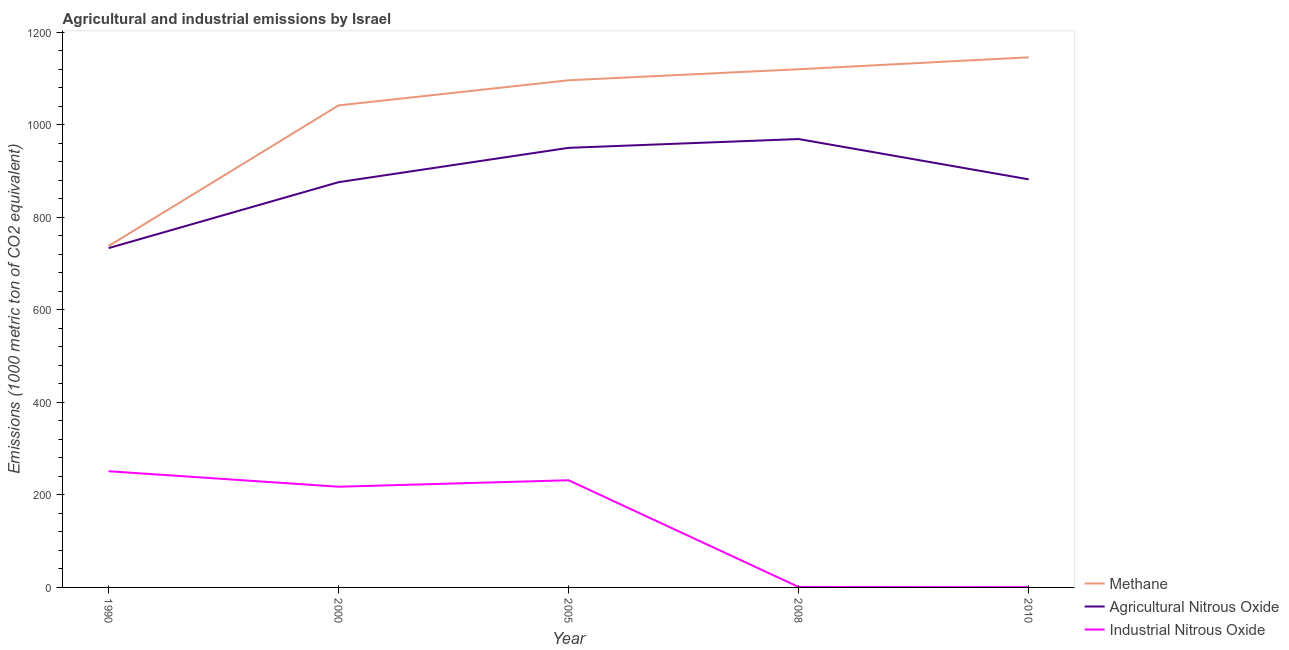What is the amount of methane emissions in 2010?
Your response must be concise. 1145.5. Across all years, what is the maximum amount of agricultural nitrous oxide emissions?
Make the answer very short. 968.9. Across all years, what is the minimum amount of methane emissions?
Give a very brief answer. 737.7. In which year was the amount of methane emissions maximum?
Ensure brevity in your answer.  2010. In which year was the amount of agricultural nitrous oxide emissions minimum?
Offer a terse response. 1990. What is the total amount of industrial nitrous oxide emissions in the graph?
Ensure brevity in your answer.  701.9. What is the difference between the amount of agricultural nitrous oxide emissions in 2005 and that in 2010?
Give a very brief answer. 68.1. What is the difference between the amount of industrial nitrous oxide emissions in 2010 and the amount of agricultural nitrous oxide emissions in 2008?
Ensure brevity in your answer.  -968.3. What is the average amount of industrial nitrous oxide emissions per year?
Provide a short and direct response. 140.38. In the year 2005, what is the difference between the amount of industrial nitrous oxide emissions and amount of methane emissions?
Give a very brief answer. -864.3. In how many years, is the amount of agricultural nitrous oxide emissions greater than 1120 metric ton?
Your answer should be compact. 0. What is the ratio of the amount of industrial nitrous oxide emissions in 2005 to that in 2008?
Your response must be concise. 231.6. Is the amount of methane emissions in 1990 less than that in 2008?
Offer a terse response. Yes. Is the difference between the amount of agricultural nitrous oxide emissions in 2000 and 2008 greater than the difference between the amount of methane emissions in 2000 and 2008?
Keep it short and to the point. No. What is the difference between the highest and the lowest amount of industrial nitrous oxide emissions?
Offer a terse response. 250.5. Is it the case that in every year, the sum of the amount of methane emissions and amount of agricultural nitrous oxide emissions is greater than the amount of industrial nitrous oxide emissions?
Make the answer very short. Yes. Does the amount of agricultural nitrous oxide emissions monotonically increase over the years?
Provide a short and direct response. No. How many lines are there?
Provide a short and direct response. 3. What is the difference between two consecutive major ticks on the Y-axis?
Keep it short and to the point. 200. Does the graph contain grids?
Offer a terse response. No. What is the title of the graph?
Ensure brevity in your answer.  Agricultural and industrial emissions by Israel. Does "Ages 15-20" appear as one of the legend labels in the graph?
Provide a succinct answer. No. What is the label or title of the X-axis?
Provide a succinct answer. Year. What is the label or title of the Y-axis?
Give a very brief answer. Emissions (1000 metric ton of CO2 equivalent). What is the Emissions (1000 metric ton of CO2 equivalent) of Methane in 1990?
Make the answer very short. 737.7. What is the Emissions (1000 metric ton of CO2 equivalent) of Agricultural Nitrous Oxide in 1990?
Your answer should be very brief. 733.2. What is the Emissions (1000 metric ton of CO2 equivalent) in Industrial Nitrous Oxide in 1990?
Provide a short and direct response. 251.1. What is the Emissions (1000 metric ton of CO2 equivalent) of Methane in 2000?
Your answer should be compact. 1041.6. What is the Emissions (1000 metric ton of CO2 equivalent) in Agricultural Nitrous Oxide in 2000?
Give a very brief answer. 875.7. What is the Emissions (1000 metric ton of CO2 equivalent) of Industrial Nitrous Oxide in 2000?
Provide a succinct answer. 217.6. What is the Emissions (1000 metric ton of CO2 equivalent) in Methane in 2005?
Provide a succinct answer. 1095.9. What is the Emissions (1000 metric ton of CO2 equivalent) of Agricultural Nitrous Oxide in 2005?
Offer a very short reply. 949.9. What is the Emissions (1000 metric ton of CO2 equivalent) of Industrial Nitrous Oxide in 2005?
Keep it short and to the point. 231.6. What is the Emissions (1000 metric ton of CO2 equivalent) of Methane in 2008?
Your answer should be very brief. 1119.7. What is the Emissions (1000 metric ton of CO2 equivalent) of Agricultural Nitrous Oxide in 2008?
Keep it short and to the point. 968.9. What is the Emissions (1000 metric ton of CO2 equivalent) of Industrial Nitrous Oxide in 2008?
Make the answer very short. 1. What is the Emissions (1000 metric ton of CO2 equivalent) of Methane in 2010?
Your answer should be compact. 1145.5. What is the Emissions (1000 metric ton of CO2 equivalent) of Agricultural Nitrous Oxide in 2010?
Ensure brevity in your answer.  881.8. Across all years, what is the maximum Emissions (1000 metric ton of CO2 equivalent) in Methane?
Your response must be concise. 1145.5. Across all years, what is the maximum Emissions (1000 metric ton of CO2 equivalent) of Agricultural Nitrous Oxide?
Ensure brevity in your answer.  968.9. Across all years, what is the maximum Emissions (1000 metric ton of CO2 equivalent) in Industrial Nitrous Oxide?
Offer a very short reply. 251.1. Across all years, what is the minimum Emissions (1000 metric ton of CO2 equivalent) in Methane?
Keep it short and to the point. 737.7. Across all years, what is the minimum Emissions (1000 metric ton of CO2 equivalent) of Agricultural Nitrous Oxide?
Your answer should be compact. 733.2. Across all years, what is the minimum Emissions (1000 metric ton of CO2 equivalent) in Industrial Nitrous Oxide?
Provide a short and direct response. 0.6. What is the total Emissions (1000 metric ton of CO2 equivalent) in Methane in the graph?
Your answer should be very brief. 5140.4. What is the total Emissions (1000 metric ton of CO2 equivalent) of Agricultural Nitrous Oxide in the graph?
Offer a terse response. 4409.5. What is the total Emissions (1000 metric ton of CO2 equivalent) of Industrial Nitrous Oxide in the graph?
Keep it short and to the point. 701.9. What is the difference between the Emissions (1000 metric ton of CO2 equivalent) of Methane in 1990 and that in 2000?
Ensure brevity in your answer.  -303.9. What is the difference between the Emissions (1000 metric ton of CO2 equivalent) of Agricultural Nitrous Oxide in 1990 and that in 2000?
Provide a short and direct response. -142.5. What is the difference between the Emissions (1000 metric ton of CO2 equivalent) of Industrial Nitrous Oxide in 1990 and that in 2000?
Provide a succinct answer. 33.5. What is the difference between the Emissions (1000 metric ton of CO2 equivalent) of Methane in 1990 and that in 2005?
Provide a short and direct response. -358.2. What is the difference between the Emissions (1000 metric ton of CO2 equivalent) in Agricultural Nitrous Oxide in 1990 and that in 2005?
Give a very brief answer. -216.7. What is the difference between the Emissions (1000 metric ton of CO2 equivalent) of Industrial Nitrous Oxide in 1990 and that in 2005?
Give a very brief answer. 19.5. What is the difference between the Emissions (1000 metric ton of CO2 equivalent) in Methane in 1990 and that in 2008?
Offer a very short reply. -382. What is the difference between the Emissions (1000 metric ton of CO2 equivalent) in Agricultural Nitrous Oxide in 1990 and that in 2008?
Offer a very short reply. -235.7. What is the difference between the Emissions (1000 metric ton of CO2 equivalent) of Industrial Nitrous Oxide in 1990 and that in 2008?
Offer a terse response. 250.1. What is the difference between the Emissions (1000 metric ton of CO2 equivalent) in Methane in 1990 and that in 2010?
Keep it short and to the point. -407.8. What is the difference between the Emissions (1000 metric ton of CO2 equivalent) in Agricultural Nitrous Oxide in 1990 and that in 2010?
Offer a terse response. -148.6. What is the difference between the Emissions (1000 metric ton of CO2 equivalent) in Industrial Nitrous Oxide in 1990 and that in 2010?
Make the answer very short. 250.5. What is the difference between the Emissions (1000 metric ton of CO2 equivalent) in Methane in 2000 and that in 2005?
Provide a succinct answer. -54.3. What is the difference between the Emissions (1000 metric ton of CO2 equivalent) of Agricultural Nitrous Oxide in 2000 and that in 2005?
Your answer should be compact. -74.2. What is the difference between the Emissions (1000 metric ton of CO2 equivalent) in Industrial Nitrous Oxide in 2000 and that in 2005?
Your response must be concise. -14. What is the difference between the Emissions (1000 metric ton of CO2 equivalent) in Methane in 2000 and that in 2008?
Your answer should be compact. -78.1. What is the difference between the Emissions (1000 metric ton of CO2 equivalent) in Agricultural Nitrous Oxide in 2000 and that in 2008?
Offer a very short reply. -93.2. What is the difference between the Emissions (1000 metric ton of CO2 equivalent) of Industrial Nitrous Oxide in 2000 and that in 2008?
Provide a short and direct response. 216.6. What is the difference between the Emissions (1000 metric ton of CO2 equivalent) in Methane in 2000 and that in 2010?
Offer a terse response. -103.9. What is the difference between the Emissions (1000 metric ton of CO2 equivalent) of Industrial Nitrous Oxide in 2000 and that in 2010?
Offer a very short reply. 217. What is the difference between the Emissions (1000 metric ton of CO2 equivalent) in Methane in 2005 and that in 2008?
Provide a succinct answer. -23.8. What is the difference between the Emissions (1000 metric ton of CO2 equivalent) in Industrial Nitrous Oxide in 2005 and that in 2008?
Keep it short and to the point. 230.6. What is the difference between the Emissions (1000 metric ton of CO2 equivalent) in Methane in 2005 and that in 2010?
Your answer should be very brief. -49.6. What is the difference between the Emissions (1000 metric ton of CO2 equivalent) in Agricultural Nitrous Oxide in 2005 and that in 2010?
Provide a succinct answer. 68.1. What is the difference between the Emissions (1000 metric ton of CO2 equivalent) in Industrial Nitrous Oxide in 2005 and that in 2010?
Ensure brevity in your answer.  231. What is the difference between the Emissions (1000 metric ton of CO2 equivalent) of Methane in 2008 and that in 2010?
Your response must be concise. -25.8. What is the difference between the Emissions (1000 metric ton of CO2 equivalent) of Agricultural Nitrous Oxide in 2008 and that in 2010?
Offer a very short reply. 87.1. What is the difference between the Emissions (1000 metric ton of CO2 equivalent) in Methane in 1990 and the Emissions (1000 metric ton of CO2 equivalent) in Agricultural Nitrous Oxide in 2000?
Give a very brief answer. -138. What is the difference between the Emissions (1000 metric ton of CO2 equivalent) in Methane in 1990 and the Emissions (1000 metric ton of CO2 equivalent) in Industrial Nitrous Oxide in 2000?
Offer a very short reply. 520.1. What is the difference between the Emissions (1000 metric ton of CO2 equivalent) in Agricultural Nitrous Oxide in 1990 and the Emissions (1000 metric ton of CO2 equivalent) in Industrial Nitrous Oxide in 2000?
Provide a succinct answer. 515.6. What is the difference between the Emissions (1000 metric ton of CO2 equivalent) in Methane in 1990 and the Emissions (1000 metric ton of CO2 equivalent) in Agricultural Nitrous Oxide in 2005?
Provide a succinct answer. -212.2. What is the difference between the Emissions (1000 metric ton of CO2 equivalent) in Methane in 1990 and the Emissions (1000 metric ton of CO2 equivalent) in Industrial Nitrous Oxide in 2005?
Ensure brevity in your answer.  506.1. What is the difference between the Emissions (1000 metric ton of CO2 equivalent) of Agricultural Nitrous Oxide in 1990 and the Emissions (1000 metric ton of CO2 equivalent) of Industrial Nitrous Oxide in 2005?
Provide a short and direct response. 501.6. What is the difference between the Emissions (1000 metric ton of CO2 equivalent) of Methane in 1990 and the Emissions (1000 metric ton of CO2 equivalent) of Agricultural Nitrous Oxide in 2008?
Give a very brief answer. -231.2. What is the difference between the Emissions (1000 metric ton of CO2 equivalent) of Methane in 1990 and the Emissions (1000 metric ton of CO2 equivalent) of Industrial Nitrous Oxide in 2008?
Your answer should be compact. 736.7. What is the difference between the Emissions (1000 metric ton of CO2 equivalent) of Agricultural Nitrous Oxide in 1990 and the Emissions (1000 metric ton of CO2 equivalent) of Industrial Nitrous Oxide in 2008?
Ensure brevity in your answer.  732.2. What is the difference between the Emissions (1000 metric ton of CO2 equivalent) in Methane in 1990 and the Emissions (1000 metric ton of CO2 equivalent) in Agricultural Nitrous Oxide in 2010?
Your answer should be compact. -144.1. What is the difference between the Emissions (1000 metric ton of CO2 equivalent) in Methane in 1990 and the Emissions (1000 metric ton of CO2 equivalent) in Industrial Nitrous Oxide in 2010?
Keep it short and to the point. 737.1. What is the difference between the Emissions (1000 metric ton of CO2 equivalent) of Agricultural Nitrous Oxide in 1990 and the Emissions (1000 metric ton of CO2 equivalent) of Industrial Nitrous Oxide in 2010?
Keep it short and to the point. 732.6. What is the difference between the Emissions (1000 metric ton of CO2 equivalent) in Methane in 2000 and the Emissions (1000 metric ton of CO2 equivalent) in Agricultural Nitrous Oxide in 2005?
Provide a succinct answer. 91.7. What is the difference between the Emissions (1000 metric ton of CO2 equivalent) of Methane in 2000 and the Emissions (1000 metric ton of CO2 equivalent) of Industrial Nitrous Oxide in 2005?
Provide a succinct answer. 810. What is the difference between the Emissions (1000 metric ton of CO2 equivalent) in Agricultural Nitrous Oxide in 2000 and the Emissions (1000 metric ton of CO2 equivalent) in Industrial Nitrous Oxide in 2005?
Your response must be concise. 644.1. What is the difference between the Emissions (1000 metric ton of CO2 equivalent) in Methane in 2000 and the Emissions (1000 metric ton of CO2 equivalent) in Agricultural Nitrous Oxide in 2008?
Offer a terse response. 72.7. What is the difference between the Emissions (1000 metric ton of CO2 equivalent) of Methane in 2000 and the Emissions (1000 metric ton of CO2 equivalent) of Industrial Nitrous Oxide in 2008?
Ensure brevity in your answer.  1040.6. What is the difference between the Emissions (1000 metric ton of CO2 equivalent) of Agricultural Nitrous Oxide in 2000 and the Emissions (1000 metric ton of CO2 equivalent) of Industrial Nitrous Oxide in 2008?
Ensure brevity in your answer.  874.7. What is the difference between the Emissions (1000 metric ton of CO2 equivalent) of Methane in 2000 and the Emissions (1000 metric ton of CO2 equivalent) of Agricultural Nitrous Oxide in 2010?
Make the answer very short. 159.8. What is the difference between the Emissions (1000 metric ton of CO2 equivalent) of Methane in 2000 and the Emissions (1000 metric ton of CO2 equivalent) of Industrial Nitrous Oxide in 2010?
Offer a terse response. 1041. What is the difference between the Emissions (1000 metric ton of CO2 equivalent) of Agricultural Nitrous Oxide in 2000 and the Emissions (1000 metric ton of CO2 equivalent) of Industrial Nitrous Oxide in 2010?
Keep it short and to the point. 875.1. What is the difference between the Emissions (1000 metric ton of CO2 equivalent) of Methane in 2005 and the Emissions (1000 metric ton of CO2 equivalent) of Agricultural Nitrous Oxide in 2008?
Your response must be concise. 127. What is the difference between the Emissions (1000 metric ton of CO2 equivalent) in Methane in 2005 and the Emissions (1000 metric ton of CO2 equivalent) in Industrial Nitrous Oxide in 2008?
Ensure brevity in your answer.  1094.9. What is the difference between the Emissions (1000 metric ton of CO2 equivalent) in Agricultural Nitrous Oxide in 2005 and the Emissions (1000 metric ton of CO2 equivalent) in Industrial Nitrous Oxide in 2008?
Offer a terse response. 948.9. What is the difference between the Emissions (1000 metric ton of CO2 equivalent) in Methane in 2005 and the Emissions (1000 metric ton of CO2 equivalent) in Agricultural Nitrous Oxide in 2010?
Your answer should be very brief. 214.1. What is the difference between the Emissions (1000 metric ton of CO2 equivalent) of Methane in 2005 and the Emissions (1000 metric ton of CO2 equivalent) of Industrial Nitrous Oxide in 2010?
Keep it short and to the point. 1095.3. What is the difference between the Emissions (1000 metric ton of CO2 equivalent) of Agricultural Nitrous Oxide in 2005 and the Emissions (1000 metric ton of CO2 equivalent) of Industrial Nitrous Oxide in 2010?
Give a very brief answer. 949.3. What is the difference between the Emissions (1000 metric ton of CO2 equivalent) of Methane in 2008 and the Emissions (1000 metric ton of CO2 equivalent) of Agricultural Nitrous Oxide in 2010?
Give a very brief answer. 237.9. What is the difference between the Emissions (1000 metric ton of CO2 equivalent) in Methane in 2008 and the Emissions (1000 metric ton of CO2 equivalent) in Industrial Nitrous Oxide in 2010?
Your answer should be compact. 1119.1. What is the difference between the Emissions (1000 metric ton of CO2 equivalent) in Agricultural Nitrous Oxide in 2008 and the Emissions (1000 metric ton of CO2 equivalent) in Industrial Nitrous Oxide in 2010?
Offer a terse response. 968.3. What is the average Emissions (1000 metric ton of CO2 equivalent) of Methane per year?
Offer a terse response. 1028.08. What is the average Emissions (1000 metric ton of CO2 equivalent) in Agricultural Nitrous Oxide per year?
Ensure brevity in your answer.  881.9. What is the average Emissions (1000 metric ton of CO2 equivalent) of Industrial Nitrous Oxide per year?
Offer a very short reply. 140.38. In the year 1990, what is the difference between the Emissions (1000 metric ton of CO2 equivalent) in Methane and Emissions (1000 metric ton of CO2 equivalent) in Agricultural Nitrous Oxide?
Your answer should be compact. 4.5. In the year 1990, what is the difference between the Emissions (1000 metric ton of CO2 equivalent) of Methane and Emissions (1000 metric ton of CO2 equivalent) of Industrial Nitrous Oxide?
Provide a succinct answer. 486.6. In the year 1990, what is the difference between the Emissions (1000 metric ton of CO2 equivalent) in Agricultural Nitrous Oxide and Emissions (1000 metric ton of CO2 equivalent) in Industrial Nitrous Oxide?
Provide a short and direct response. 482.1. In the year 2000, what is the difference between the Emissions (1000 metric ton of CO2 equivalent) in Methane and Emissions (1000 metric ton of CO2 equivalent) in Agricultural Nitrous Oxide?
Provide a succinct answer. 165.9. In the year 2000, what is the difference between the Emissions (1000 metric ton of CO2 equivalent) in Methane and Emissions (1000 metric ton of CO2 equivalent) in Industrial Nitrous Oxide?
Give a very brief answer. 824. In the year 2000, what is the difference between the Emissions (1000 metric ton of CO2 equivalent) in Agricultural Nitrous Oxide and Emissions (1000 metric ton of CO2 equivalent) in Industrial Nitrous Oxide?
Give a very brief answer. 658.1. In the year 2005, what is the difference between the Emissions (1000 metric ton of CO2 equivalent) of Methane and Emissions (1000 metric ton of CO2 equivalent) of Agricultural Nitrous Oxide?
Provide a short and direct response. 146. In the year 2005, what is the difference between the Emissions (1000 metric ton of CO2 equivalent) of Methane and Emissions (1000 metric ton of CO2 equivalent) of Industrial Nitrous Oxide?
Give a very brief answer. 864.3. In the year 2005, what is the difference between the Emissions (1000 metric ton of CO2 equivalent) of Agricultural Nitrous Oxide and Emissions (1000 metric ton of CO2 equivalent) of Industrial Nitrous Oxide?
Offer a terse response. 718.3. In the year 2008, what is the difference between the Emissions (1000 metric ton of CO2 equivalent) of Methane and Emissions (1000 metric ton of CO2 equivalent) of Agricultural Nitrous Oxide?
Provide a short and direct response. 150.8. In the year 2008, what is the difference between the Emissions (1000 metric ton of CO2 equivalent) in Methane and Emissions (1000 metric ton of CO2 equivalent) in Industrial Nitrous Oxide?
Your answer should be very brief. 1118.7. In the year 2008, what is the difference between the Emissions (1000 metric ton of CO2 equivalent) in Agricultural Nitrous Oxide and Emissions (1000 metric ton of CO2 equivalent) in Industrial Nitrous Oxide?
Offer a very short reply. 967.9. In the year 2010, what is the difference between the Emissions (1000 metric ton of CO2 equivalent) in Methane and Emissions (1000 metric ton of CO2 equivalent) in Agricultural Nitrous Oxide?
Your response must be concise. 263.7. In the year 2010, what is the difference between the Emissions (1000 metric ton of CO2 equivalent) of Methane and Emissions (1000 metric ton of CO2 equivalent) of Industrial Nitrous Oxide?
Make the answer very short. 1144.9. In the year 2010, what is the difference between the Emissions (1000 metric ton of CO2 equivalent) of Agricultural Nitrous Oxide and Emissions (1000 metric ton of CO2 equivalent) of Industrial Nitrous Oxide?
Your response must be concise. 881.2. What is the ratio of the Emissions (1000 metric ton of CO2 equivalent) of Methane in 1990 to that in 2000?
Give a very brief answer. 0.71. What is the ratio of the Emissions (1000 metric ton of CO2 equivalent) in Agricultural Nitrous Oxide in 1990 to that in 2000?
Give a very brief answer. 0.84. What is the ratio of the Emissions (1000 metric ton of CO2 equivalent) in Industrial Nitrous Oxide in 1990 to that in 2000?
Offer a very short reply. 1.15. What is the ratio of the Emissions (1000 metric ton of CO2 equivalent) in Methane in 1990 to that in 2005?
Your answer should be very brief. 0.67. What is the ratio of the Emissions (1000 metric ton of CO2 equivalent) of Agricultural Nitrous Oxide in 1990 to that in 2005?
Give a very brief answer. 0.77. What is the ratio of the Emissions (1000 metric ton of CO2 equivalent) in Industrial Nitrous Oxide in 1990 to that in 2005?
Your answer should be compact. 1.08. What is the ratio of the Emissions (1000 metric ton of CO2 equivalent) in Methane in 1990 to that in 2008?
Give a very brief answer. 0.66. What is the ratio of the Emissions (1000 metric ton of CO2 equivalent) of Agricultural Nitrous Oxide in 1990 to that in 2008?
Offer a very short reply. 0.76. What is the ratio of the Emissions (1000 metric ton of CO2 equivalent) in Industrial Nitrous Oxide in 1990 to that in 2008?
Provide a short and direct response. 251.1. What is the ratio of the Emissions (1000 metric ton of CO2 equivalent) in Methane in 1990 to that in 2010?
Make the answer very short. 0.64. What is the ratio of the Emissions (1000 metric ton of CO2 equivalent) in Agricultural Nitrous Oxide in 1990 to that in 2010?
Offer a very short reply. 0.83. What is the ratio of the Emissions (1000 metric ton of CO2 equivalent) in Industrial Nitrous Oxide in 1990 to that in 2010?
Provide a short and direct response. 418.5. What is the ratio of the Emissions (1000 metric ton of CO2 equivalent) in Methane in 2000 to that in 2005?
Your response must be concise. 0.95. What is the ratio of the Emissions (1000 metric ton of CO2 equivalent) in Agricultural Nitrous Oxide in 2000 to that in 2005?
Provide a succinct answer. 0.92. What is the ratio of the Emissions (1000 metric ton of CO2 equivalent) of Industrial Nitrous Oxide in 2000 to that in 2005?
Give a very brief answer. 0.94. What is the ratio of the Emissions (1000 metric ton of CO2 equivalent) of Methane in 2000 to that in 2008?
Your answer should be very brief. 0.93. What is the ratio of the Emissions (1000 metric ton of CO2 equivalent) of Agricultural Nitrous Oxide in 2000 to that in 2008?
Your response must be concise. 0.9. What is the ratio of the Emissions (1000 metric ton of CO2 equivalent) of Industrial Nitrous Oxide in 2000 to that in 2008?
Provide a short and direct response. 217.6. What is the ratio of the Emissions (1000 metric ton of CO2 equivalent) in Methane in 2000 to that in 2010?
Make the answer very short. 0.91. What is the ratio of the Emissions (1000 metric ton of CO2 equivalent) of Industrial Nitrous Oxide in 2000 to that in 2010?
Offer a terse response. 362.67. What is the ratio of the Emissions (1000 metric ton of CO2 equivalent) in Methane in 2005 to that in 2008?
Provide a succinct answer. 0.98. What is the ratio of the Emissions (1000 metric ton of CO2 equivalent) of Agricultural Nitrous Oxide in 2005 to that in 2008?
Keep it short and to the point. 0.98. What is the ratio of the Emissions (1000 metric ton of CO2 equivalent) of Industrial Nitrous Oxide in 2005 to that in 2008?
Give a very brief answer. 231.6. What is the ratio of the Emissions (1000 metric ton of CO2 equivalent) of Methane in 2005 to that in 2010?
Make the answer very short. 0.96. What is the ratio of the Emissions (1000 metric ton of CO2 equivalent) in Agricultural Nitrous Oxide in 2005 to that in 2010?
Your answer should be very brief. 1.08. What is the ratio of the Emissions (1000 metric ton of CO2 equivalent) in Industrial Nitrous Oxide in 2005 to that in 2010?
Offer a very short reply. 386. What is the ratio of the Emissions (1000 metric ton of CO2 equivalent) of Methane in 2008 to that in 2010?
Your response must be concise. 0.98. What is the ratio of the Emissions (1000 metric ton of CO2 equivalent) of Agricultural Nitrous Oxide in 2008 to that in 2010?
Your answer should be very brief. 1.1. What is the difference between the highest and the second highest Emissions (1000 metric ton of CO2 equivalent) of Methane?
Make the answer very short. 25.8. What is the difference between the highest and the second highest Emissions (1000 metric ton of CO2 equivalent) in Agricultural Nitrous Oxide?
Provide a short and direct response. 19. What is the difference between the highest and the second highest Emissions (1000 metric ton of CO2 equivalent) of Industrial Nitrous Oxide?
Your answer should be compact. 19.5. What is the difference between the highest and the lowest Emissions (1000 metric ton of CO2 equivalent) in Methane?
Provide a succinct answer. 407.8. What is the difference between the highest and the lowest Emissions (1000 metric ton of CO2 equivalent) of Agricultural Nitrous Oxide?
Offer a very short reply. 235.7. What is the difference between the highest and the lowest Emissions (1000 metric ton of CO2 equivalent) in Industrial Nitrous Oxide?
Offer a very short reply. 250.5. 